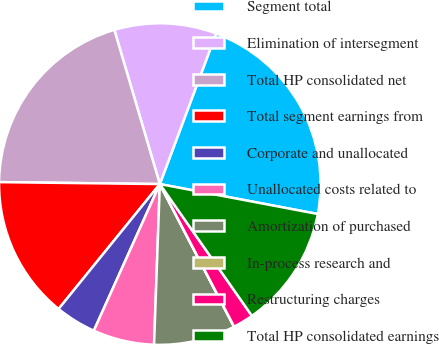<chart> <loc_0><loc_0><loc_500><loc_500><pie_chart><fcel>Segment total<fcel>Elimination of intersegment<fcel>Total HP consolidated net<fcel>Total segment earnings from<fcel>Corporate and unallocated<fcel>Unallocated costs related to<fcel>Amortization of purchased<fcel>In-process research and<fcel>Restructuring charges<fcel>Total HP consolidated earnings<nl><fcel>22.29%<fcel>10.26%<fcel>20.24%<fcel>14.35%<fcel>4.11%<fcel>6.16%<fcel>8.21%<fcel>0.01%<fcel>2.06%<fcel>12.31%<nl></chart> 